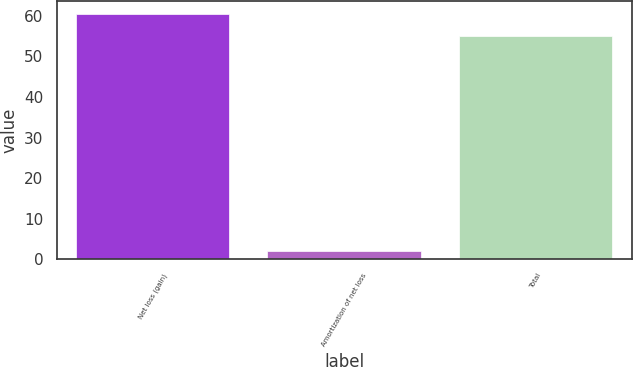Convert chart. <chart><loc_0><loc_0><loc_500><loc_500><bar_chart><fcel>Net loss (gain)<fcel>Amortization of net loss<fcel>Total<nl><fcel>60.5<fcel>2<fcel>55<nl></chart> 